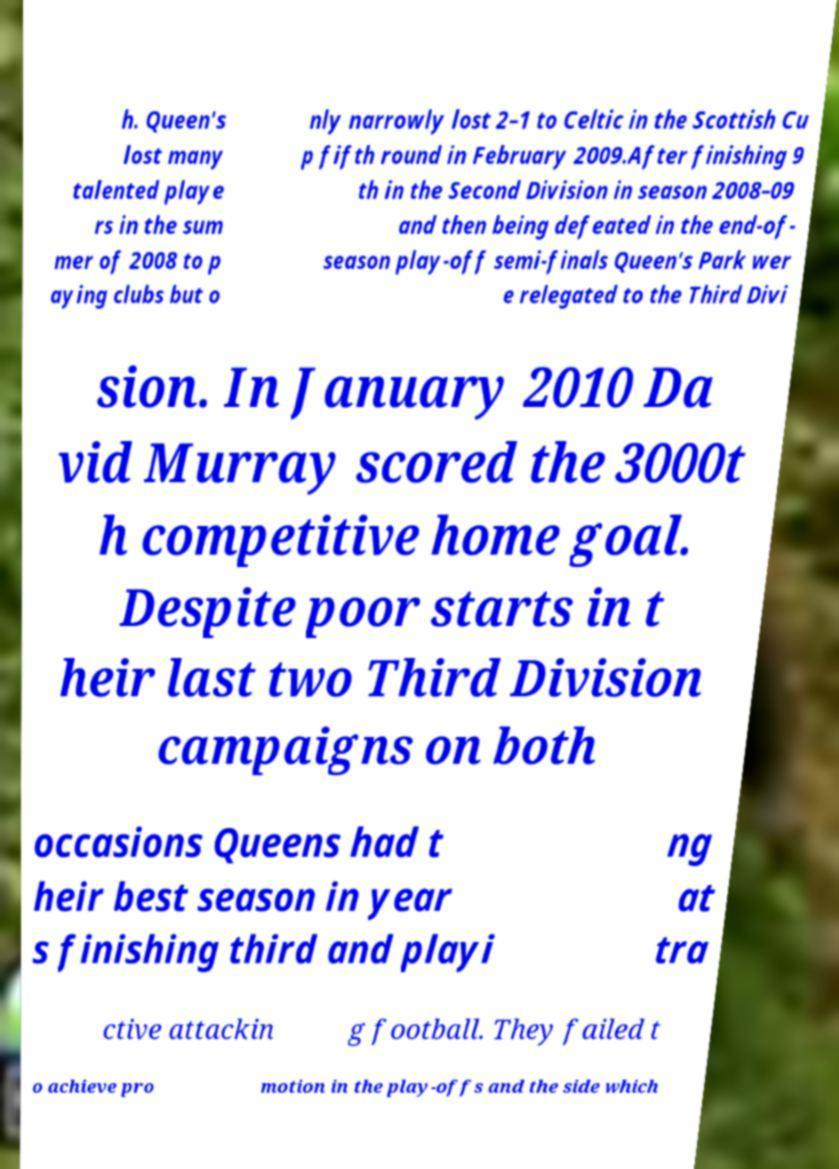Please identify and transcribe the text found in this image. h. Queen's lost many talented playe rs in the sum mer of 2008 to p aying clubs but o nly narrowly lost 2–1 to Celtic in the Scottish Cu p fifth round in February 2009.After finishing 9 th in the Second Division in season 2008–09 and then being defeated in the end-of- season play-off semi-finals Queen's Park wer e relegated to the Third Divi sion. In January 2010 Da vid Murray scored the 3000t h competitive home goal. Despite poor starts in t heir last two Third Division campaigns on both occasions Queens had t heir best season in year s finishing third and playi ng at tra ctive attackin g football. They failed t o achieve pro motion in the play-offs and the side which 